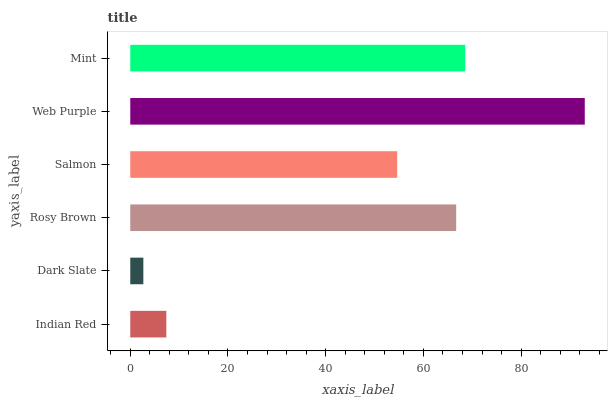Is Dark Slate the minimum?
Answer yes or no. Yes. Is Web Purple the maximum?
Answer yes or no. Yes. Is Rosy Brown the minimum?
Answer yes or no. No. Is Rosy Brown the maximum?
Answer yes or no. No. Is Rosy Brown greater than Dark Slate?
Answer yes or no. Yes. Is Dark Slate less than Rosy Brown?
Answer yes or no. Yes. Is Dark Slate greater than Rosy Brown?
Answer yes or no. No. Is Rosy Brown less than Dark Slate?
Answer yes or no. No. Is Rosy Brown the high median?
Answer yes or no. Yes. Is Salmon the low median?
Answer yes or no. Yes. Is Salmon the high median?
Answer yes or no. No. Is Rosy Brown the low median?
Answer yes or no. No. 